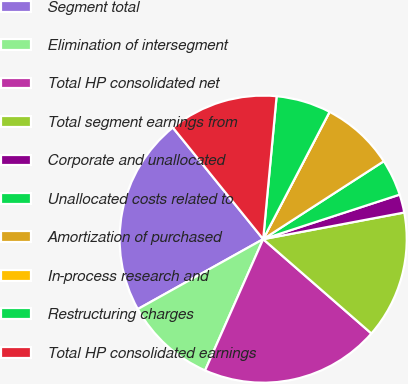Convert chart to OTSL. <chart><loc_0><loc_0><loc_500><loc_500><pie_chart><fcel>Segment total<fcel>Elimination of intersegment<fcel>Total HP consolidated net<fcel>Total segment earnings from<fcel>Corporate and unallocated<fcel>Unallocated costs related to<fcel>Amortization of purchased<fcel>In-process research and<fcel>Restructuring charges<fcel>Total HP consolidated earnings<nl><fcel>22.27%<fcel>10.27%<fcel>20.22%<fcel>14.38%<fcel>2.05%<fcel>4.11%<fcel>8.22%<fcel>0.0%<fcel>6.16%<fcel>12.32%<nl></chart> 